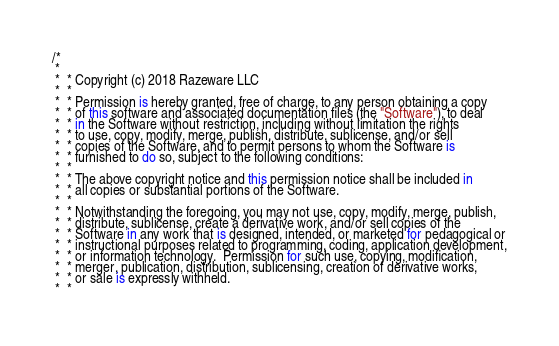Convert code to text. <code><loc_0><loc_0><loc_500><loc_500><_Kotlin_>/*
 *
 *  * Copyright (c) 2018 Razeware LLC
 *  *
 *  * Permission is hereby granted, free of charge, to any person obtaining a copy
 *  * of this software and associated documentation files (the "Software"), to deal
 *  * in the Software without restriction, including without limitation the rights
 *  * to use, copy, modify, merge, publish, distribute, sublicense, and/or sell
 *  * copies of the Software, and to permit persons to whom the Software is
 *  * furnished to do so, subject to the following conditions:
 *  *
 *  * The above copyright notice and this permission notice shall be included in
 *  * all copies or substantial portions of the Software.
 *  *
 *  * Notwithstanding the foregoing, you may not use, copy, modify, merge, publish,
 *  * distribute, sublicense, create a derivative work, and/or sell copies of the
 *  * Software in any work that is designed, intended, or marketed for pedagogical or
 *  * instructional purposes related to programming, coding, application development,
 *  * or information technology.  Permission for such use, copying, modification,
 *  * merger, publication, distribution, sublicensing, creation of derivative works,
 *  * or sale is expressly withheld.
 *  *</code> 